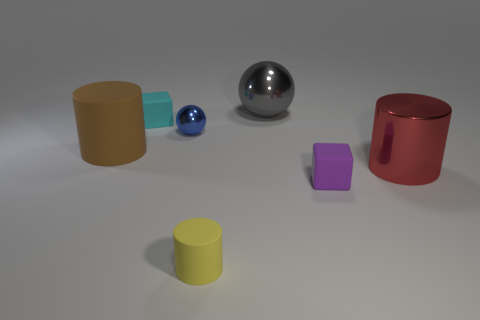What is the shape of the tiny blue thing?
Offer a very short reply. Sphere. Are there any tiny cylinders that have the same color as the tiny metal sphere?
Your answer should be very brief. No. Are there more big brown matte objects that are to the right of the cyan matte object than red cylinders?
Your answer should be compact. No. Is the shape of the red metal object the same as the small yellow matte object to the right of the tiny blue ball?
Ensure brevity in your answer.  Yes. Are any cylinders visible?
Provide a short and direct response. Yes. How many large things are gray shiny spheres or blue things?
Provide a short and direct response. 1. Are there more metallic objects on the right side of the large metal ball than small yellow objects right of the small yellow rubber thing?
Make the answer very short. Yes. Is the material of the large gray sphere the same as the tiny cube that is to the left of the small sphere?
Offer a very short reply. No. What color is the large metal cylinder?
Your answer should be very brief. Red. There is a metal thing behind the cyan matte thing; what is its shape?
Your answer should be compact. Sphere. 